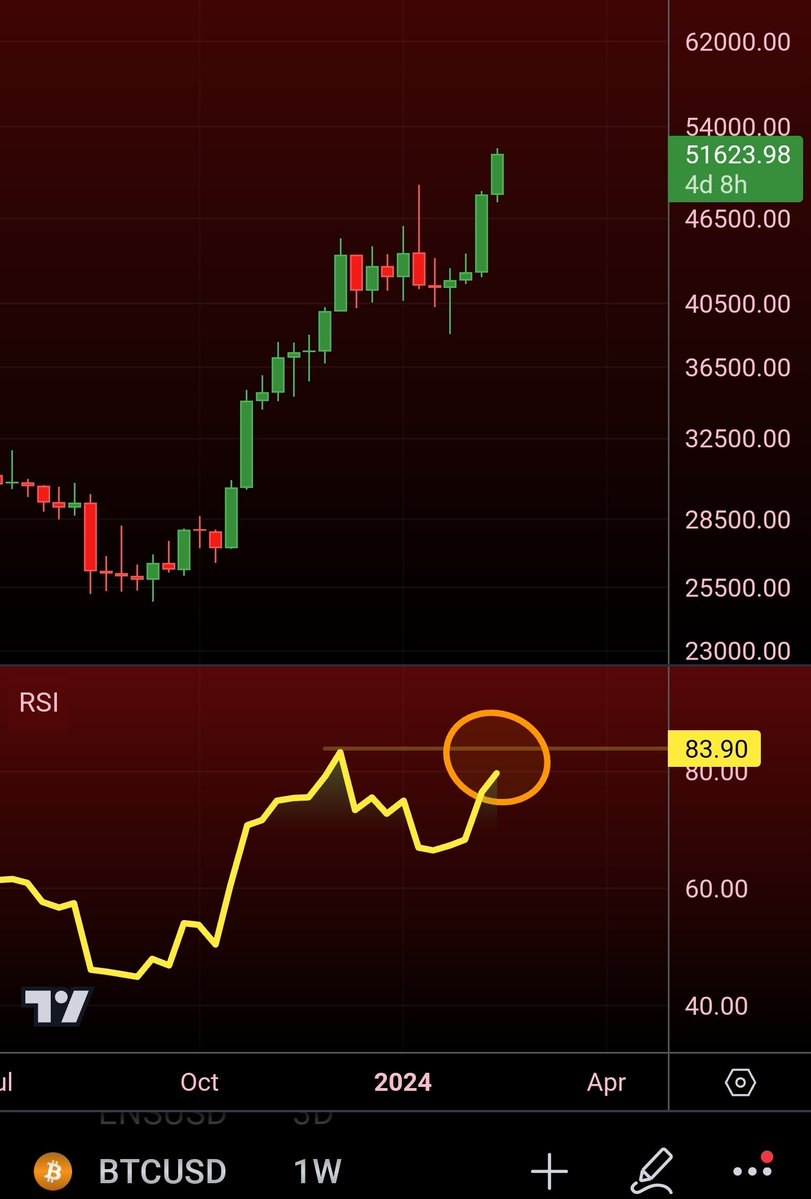should i buy or sell ? I'm sorry, but I cannot provide personalized financial advice, including specific recommendations to buy or sell securities or cryptocurrencies. The decision to buy or sell an asset should be based on your own research, your financial situation, your investment goals, and your risk tolerance. It's important to consider seeking advice from a financial advisor who can take into account your individual circumstances.

The image you provided appears to be a screenshot of a trading chart for Bitcoin against the US Dollar (BTCUSD) with an indication of the Relative Strength Index (RSI). The RSI is a momentum indicator that measures the speed and change of price movements. Generally, an RSI above 70 is considered overbought, and an RSI below 30 is considered oversold. The RSI in the image is marked around 83.90, which could suggest that Bitcoin is potentially overbought at that moment. However, technical indicators like RSI are just one of many tools investors use, and they should not be used in isolation when making trading decisions. Always consider multiple factors and analysis methods before making any trades. 